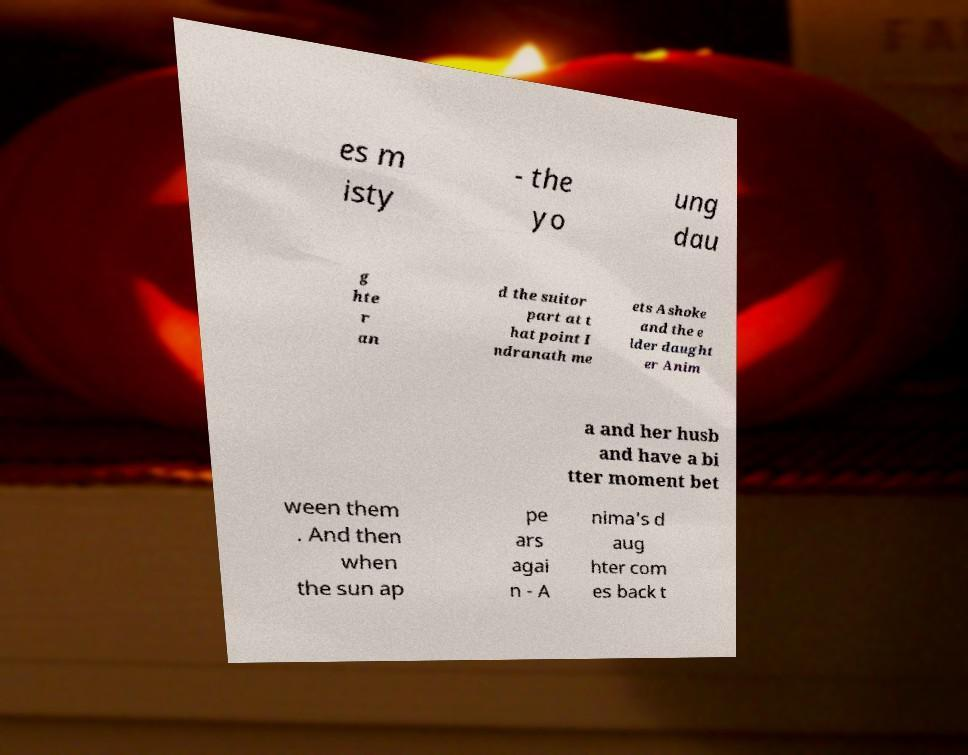Could you assist in decoding the text presented in this image and type it out clearly? es m isty - the yo ung dau g hte r an d the suitor part at t hat point I ndranath me ets Ashoke and the e lder daught er Anim a and her husb and have a bi tter moment bet ween them . And then when the sun ap pe ars agai n - A nima's d aug hter com es back t 